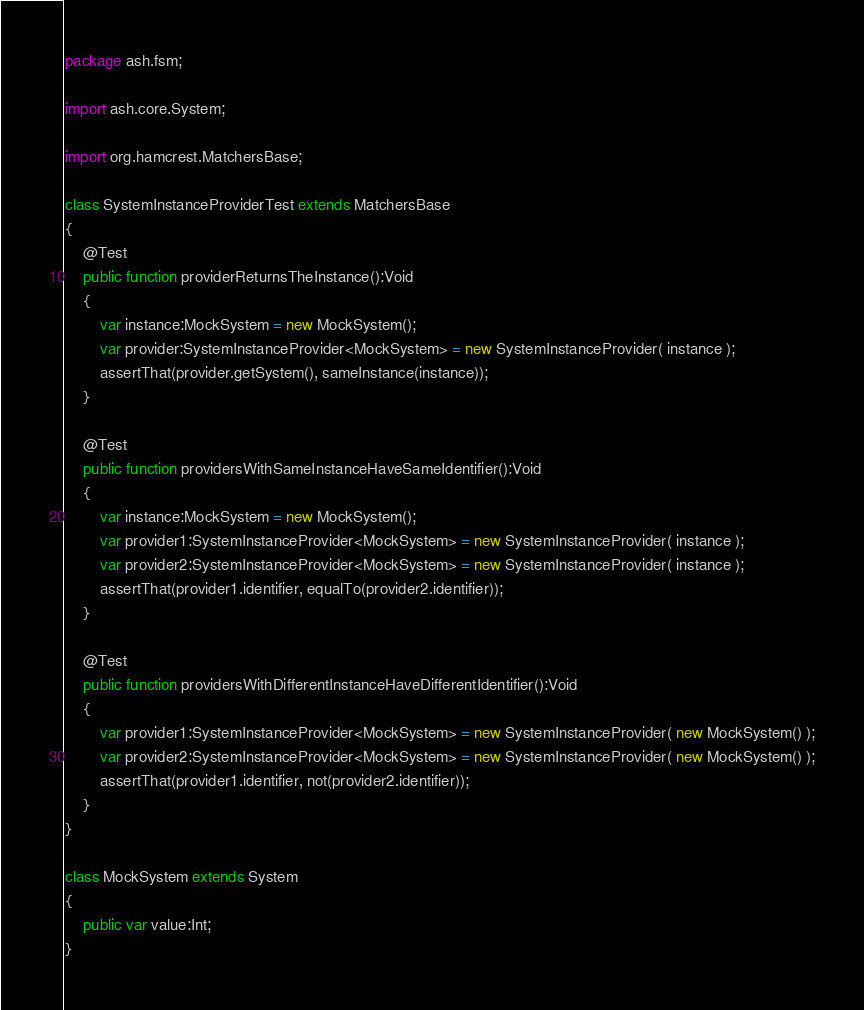<code> <loc_0><loc_0><loc_500><loc_500><_Haxe_>package ash.fsm;

import ash.core.System;

import org.hamcrest.MatchersBase;

class SystemInstanceProviderTest extends MatchersBase
{
    @Test
    public function providerReturnsTheInstance():Void
    {
        var instance:MockSystem = new MockSystem();
        var provider:SystemInstanceProvider<MockSystem> = new SystemInstanceProvider( instance );
        assertThat(provider.getSystem(), sameInstance(instance));
    }

    @Test
    public function providersWithSameInstanceHaveSameIdentifier():Void
    {
        var instance:MockSystem = new MockSystem();
        var provider1:SystemInstanceProvider<MockSystem> = new SystemInstanceProvider( instance );
        var provider2:SystemInstanceProvider<MockSystem> = new SystemInstanceProvider( instance );
        assertThat(provider1.identifier, equalTo(provider2.identifier));
    }

    @Test
    public function providersWithDifferentInstanceHaveDifferentIdentifier():Void
    {
        var provider1:SystemInstanceProvider<MockSystem> = new SystemInstanceProvider( new MockSystem() );
        var provider2:SystemInstanceProvider<MockSystem> = new SystemInstanceProvider( new MockSystem() );
        assertThat(provider1.identifier, not(provider2.identifier));
    }
}

class MockSystem extends System
{
    public var value:Int;
}
</code> 